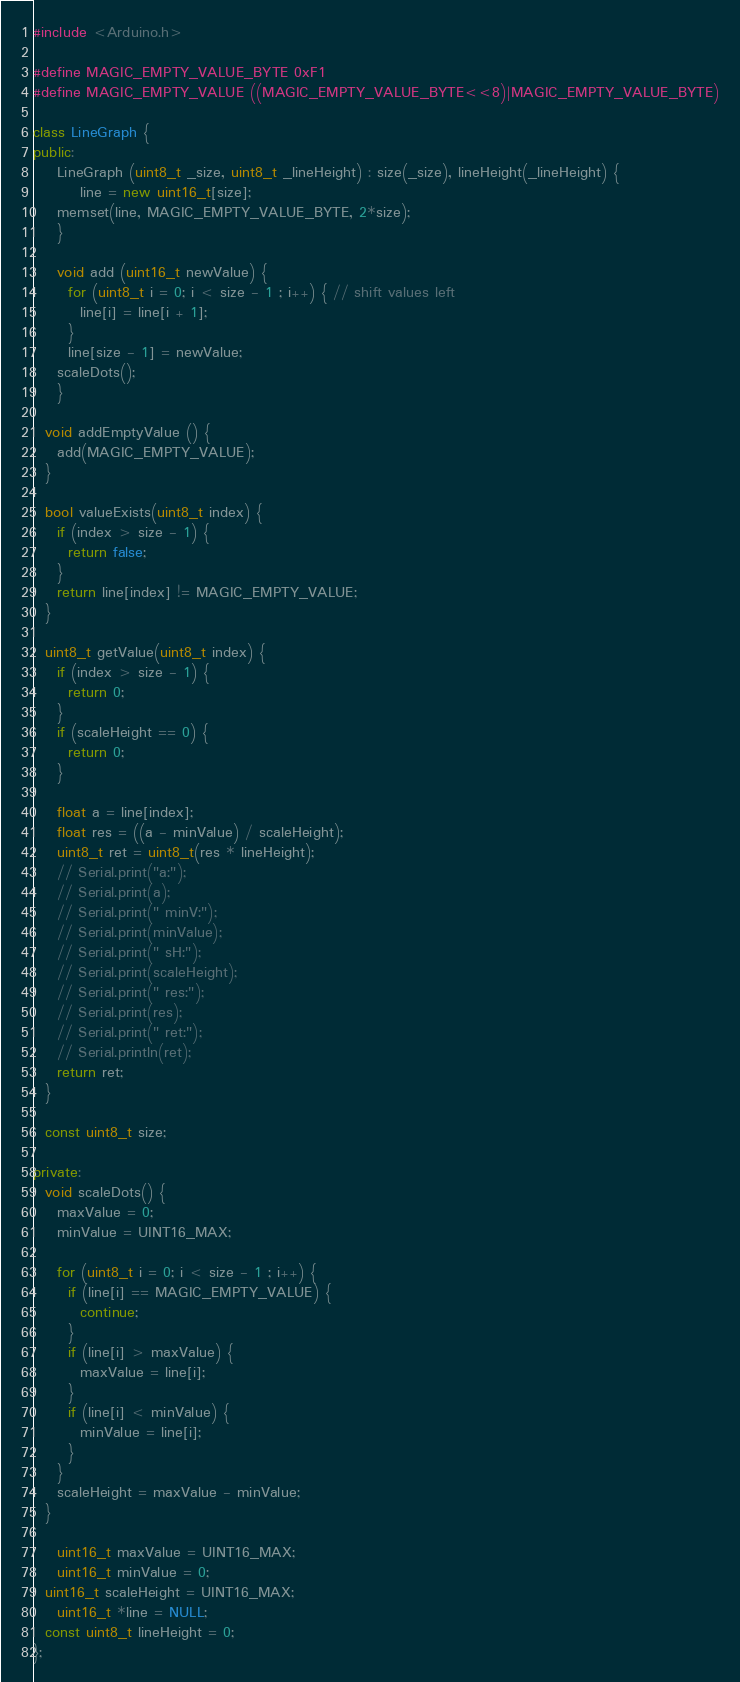Convert code to text. <code><loc_0><loc_0><loc_500><loc_500><_C++_>#include <Arduino.h>

#define MAGIC_EMPTY_VALUE_BYTE 0xF1
#define MAGIC_EMPTY_VALUE ((MAGIC_EMPTY_VALUE_BYTE<<8)|MAGIC_EMPTY_VALUE_BYTE)

class LineGraph {
public:
	LineGraph (uint8_t _size, uint8_t _lineHeight) : size(_size), lineHeight(_lineHeight) {
		line = new uint16_t[size];
    memset(line, MAGIC_EMPTY_VALUE_BYTE, 2*size);
	}

	void add (uint16_t newValue) {
	  for (uint8_t i = 0; i < size - 1 ; i++) { // shift values left
	    line[i] = line[i + 1];
	  }
	  line[size - 1] = newValue;
    scaleDots();
	}

  void addEmptyValue () {
    add(MAGIC_EMPTY_VALUE);
  }

  bool valueExists(uint8_t index) {
    if (index > size - 1) {
      return false;
    }
    return line[index] != MAGIC_EMPTY_VALUE;
  }

  uint8_t getValue(uint8_t index) {
    if (index > size - 1) {
      return 0;
    }
    if (scaleHeight == 0) {
      return 0;
    }

    float a = line[index];
    float res = ((a - minValue) / scaleHeight);
    uint8_t ret = uint8_t(res * lineHeight);
    // Serial.print("a:");
    // Serial.print(a);
    // Serial.print(" minV:");
    // Serial.print(minValue);
    // Serial.print(" sH:");
    // Serial.print(scaleHeight);
    // Serial.print(" res:");
    // Serial.print(res);
    // Serial.print(" ret:");
    // Serial.println(ret);
    return ret;
  }

  const uint8_t size;

private:
  void scaleDots() {
    maxValue = 0;
    minValue = UINT16_MAX;

    for (uint8_t i = 0; i < size - 1 ; i++) {
      if (line[i] == MAGIC_EMPTY_VALUE) {
        continue;
      }
      if (line[i] > maxValue) {
        maxValue = line[i];
      }
      if (line[i] < minValue) {
        minValue = line[i];
      }
    }
    scaleHeight = maxValue - minValue;
  }

	uint16_t maxValue = UINT16_MAX;
	uint16_t minValue = 0;
  uint16_t scaleHeight = UINT16_MAX;
	uint16_t *line = NULL;
  const uint8_t lineHeight = 0;
};</code> 